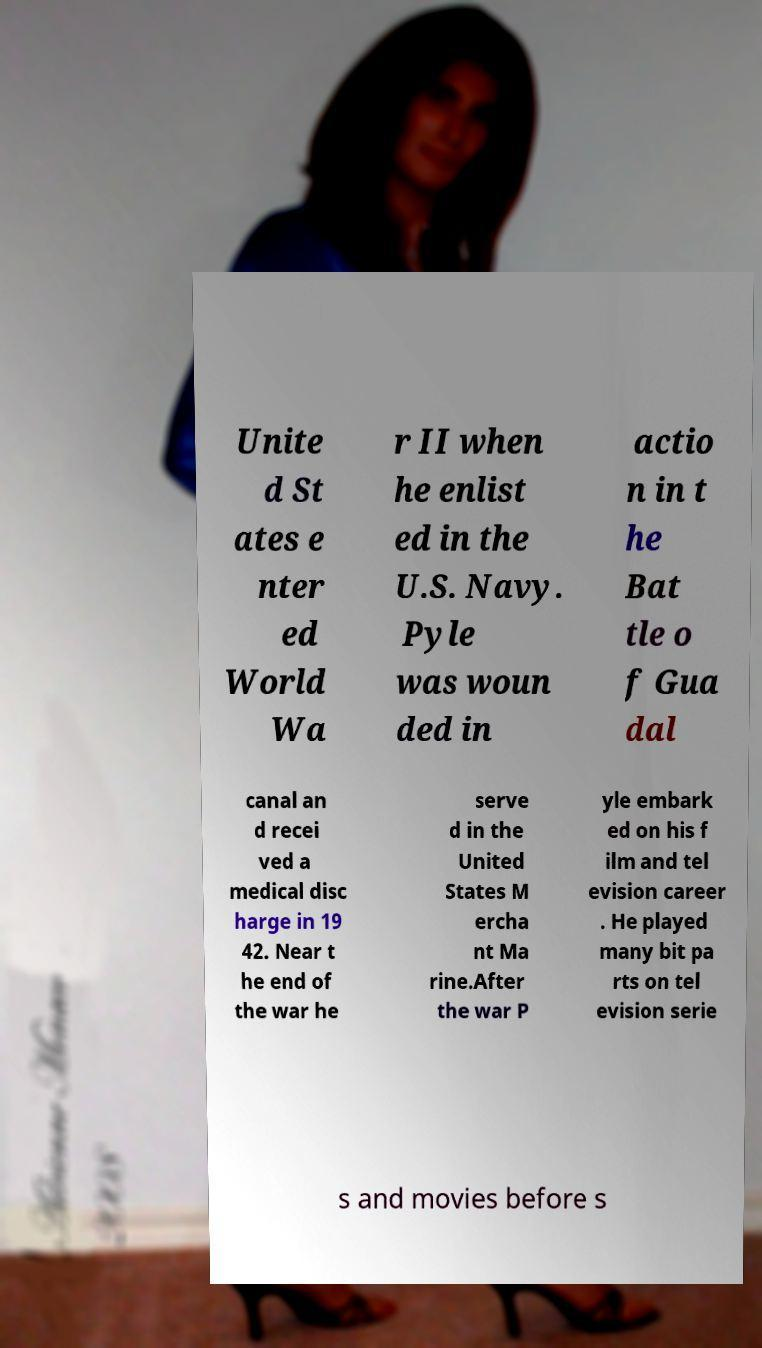Can you read and provide the text displayed in the image?This photo seems to have some interesting text. Can you extract and type it out for me? Unite d St ates e nter ed World Wa r II when he enlist ed in the U.S. Navy. Pyle was woun ded in actio n in t he Bat tle o f Gua dal canal an d recei ved a medical disc harge in 19 42. Near t he end of the war he serve d in the United States M ercha nt Ma rine.After the war P yle embark ed on his f ilm and tel evision career . He played many bit pa rts on tel evision serie s and movies before s 